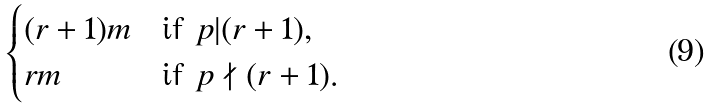<formula> <loc_0><loc_0><loc_500><loc_500>\begin{cases} ( r + 1 ) m & \text {if } p | ( r + 1 ) , \\ r m & \text {if } p \nmid ( r + 1 ) . \\ \end{cases}</formula> 